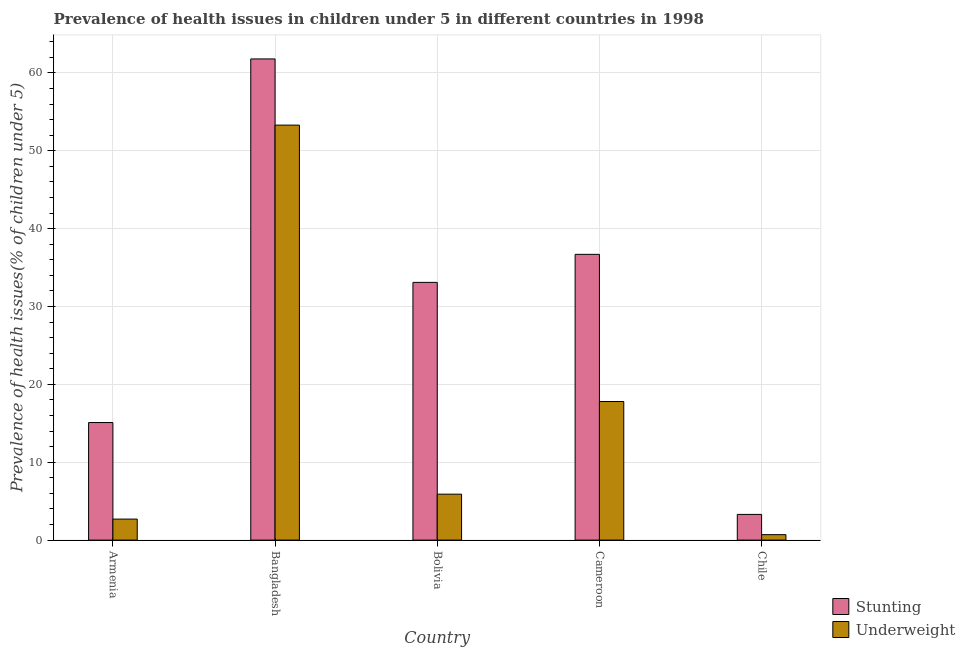How many groups of bars are there?
Provide a succinct answer. 5. How many bars are there on the 4th tick from the right?
Provide a succinct answer. 2. In how many cases, is the number of bars for a given country not equal to the number of legend labels?
Your answer should be very brief. 0. What is the percentage of stunted children in Bolivia?
Offer a very short reply. 33.1. Across all countries, what is the maximum percentage of stunted children?
Make the answer very short. 61.8. Across all countries, what is the minimum percentage of underweight children?
Your response must be concise. 0.7. In which country was the percentage of stunted children maximum?
Keep it short and to the point. Bangladesh. In which country was the percentage of stunted children minimum?
Offer a very short reply. Chile. What is the total percentage of underweight children in the graph?
Give a very brief answer. 80.4. What is the difference between the percentage of stunted children in Armenia and that in Cameroon?
Your answer should be very brief. -21.6. What is the difference between the percentage of underweight children in Bolivia and the percentage of stunted children in Armenia?
Offer a very short reply. -9.2. What is the average percentage of stunted children per country?
Provide a succinct answer. 30. What is the difference between the percentage of underweight children and percentage of stunted children in Bangladesh?
Provide a succinct answer. -8.5. In how many countries, is the percentage of underweight children greater than 30 %?
Your answer should be very brief. 1. What is the ratio of the percentage of stunted children in Cameroon to that in Chile?
Your response must be concise. 11.12. Is the percentage of stunted children in Armenia less than that in Bolivia?
Provide a short and direct response. Yes. What is the difference between the highest and the second highest percentage of stunted children?
Your answer should be compact. 25.1. What is the difference between the highest and the lowest percentage of underweight children?
Your answer should be compact. 52.6. Is the sum of the percentage of underweight children in Bangladesh and Cameroon greater than the maximum percentage of stunted children across all countries?
Offer a very short reply. Yes. What does the 1st bar from the left in Bangladesh represents?
Ensure brevity in your answer.  Stunting. What does the 2nd bar from the right in Bolivia represents?
Offer a very short reply. Stunting. Are all the bars in the graph horizontal?
Your answer should be compact. No. Does the graph contain grids?
Keep it short and to the point. Yes. What is the title of the graph?
Keep it short and to the point. Prevalence of health issues in children under 5 in different countries in 1998. What is the label or title of the Y-axis?
Ensure brevity in your answer.  Prevalence of health issues(% of children under 5). What is the Prevalence of health issues(% of children under 5) in Stunting in Armenia?
Your answer should be very brief. 15.1. What is the Prevalence of health issues(% of children under 5) in Underweight in Armenia?
Offer a terse response. 2.7. What is the Prevalence of health issues(% of children under 5) in Stunting in Bangladesh?
Give a very brief answer. 61.8. What is the Prevalence of health issues(% of children under 5) of Underweight in Bangladesh?
Your answer should be very brief. 53.3. What is the Prevalence of health issues(% of children under 5) of Stunting in Bolivia?
Make the answer very short. 33.1. What is the Prevalence of health issues(% of children under 5) in Underweight in Bolivia?
Your response must be concise. 5.9. What is the Prevalence of health issues(% of children under 5) in Stunting in Cameroon?
Offer a terse response. 36.7. What is the Prevalence of health issues(% of children under 5) of Underweight in Cameroon?
Provide a short and direct response. 17.8. What is the Prevalence of health issues(% of children under 5) of Stunting in Chile?
Give a very brief answer. 3.3. What is the Prevalence of health issues(% of children under 5) of Underweight in Chile?
Provide a short and direct response. 0.7. Across all countries, what is the maximum Prevalence of health issues(% of children under 5) in Stunting?
Keep it short and to the point. 61.8. Across all countries, what is the maximum Prevalence of health issues(% of children under 5) of Underweight?
Give a very brief answer. 53.3. Across all countries, what is the minimum Prevalence of health issues(% of children under 5) of Stunting?
Offer a terse response. 3.3. Across all countries, what is the minimum Prevalence of health issues(% of children under 5) of Underweight?
Your answer should be very brief. 0.7. What is the total Prevalence of health issues(% of children under 5) in Stunting in the graph?
Your response must be concise. 150. What is the total Prevalence of health issues(% of children under 5) in Underweight in the graph?
Provide a succinct answer. 80.4. What is the difference between the Prevalence of health issues(% of children under 5) of Stunting in Armenia and that in Bangladesh?
Keep it short and to the point. -46.7. What is the difference between the Prevalence of health issues(% of children under 5) in Underweight in Armenia and that in Bangladesh?
Ensure brevity in your answer.  -50.6. What is the difference between the Prevalence of health issues(% of children under 5) of Stunting in Armenia and that in Bolivia?
Ensure brevity in your answer.  -18. What is the difference between the Prevalence of health issues(% of children under 5) of Underweight in Armenia and that in Bolivia?
Provide a succinct answer. -3.2. What is the difference between the Prevalence of health issues(% of children under 5) in Stunting in Armenia and that in Cameroon?
Offer a terse response. -21.6. What is the difference between the Prevalence of health issues(% of children under 5) of Underweight in Armenia and that in Cameroon?
Ensure brevity in your answer.  -15.1. What is the difference between the Prevalence of health issues(% of children under 5) of Stunting in Bangladesh and that in Bolivia?
Make the answer very short. 28.7. What is the difference between the Prevalence of health issues(% of children under 5) of Underweight in Bangladesh and that in Bolivia?
Give a very brief answer. 47.4. What is the difference between the Prevalence of health issues(% of children under 5) in Stunting in Bangladesh and that in Cameroon?
Your answer should be compact. 25.1. What is the difference between the Prevalence of health issues(% of children under 5) of Underweight in Bangladesh and that in Cameroon?
Your answer should be compact. 35.5. What is the difference between the Prevalence of health issues(% of children under 5) of Stunting in Bangladesh and that in Chile?
Ensure brevity in your answer.  58.5. What is the difference between the Prevalence of health issues(% of children under 5) in Underweight in Bangladesh and that in Chile?
Make the answer very short. 52.6. What is the difference between the Prevalence of health issues(% of children under 5) in Stunting in Bolivia and that in Cameroon?
Offer a very short reply. -3.6. What is the difference between the Prevalence of health issues(% of children under 5) in Underweight in Bolivia and that in Cameroon?
Provide a short and direct response. -11.9. What is the difference between the Prevalence of health issues(% of children under 5) in Stunting in Bolivia and that in Chile?
Keep it short and to the point. 29.8. What is the difference between the Prevalence of health issues(% of children under 5) in Stunting in Cameroon and that in Chile?
Provide a succinct answer. 33.4. What is the difference between the Prevalence of health issues(% of children under 5) in Stunting in Armenia and the Prevalence of health issues(% of children under 5) in Underweight in Bangladesh?
Offer a terse response. -38.2. What is the difference between the Prevalence of health issues(% of children under 5) of Stunting in Bangladesh and the Prevalence of health issues(% of children under 5) of Underweight in Bolivia?
Provide a short and direct response. 55.9. What is the difference between the Prevalence of health issues(% of children under 5) in Stunting in Bangladesh and the Prevalence of health issues(% of children under 5) in Underweight in Cameroon?
Provide a short and direct response. 44. What is the difference between the Prevalence of health issues(% of children under 5) in Stunting in Bangladesh and the Prevalence of health issues(% of children under 5) in Underweight in Chile?
Provide a short and direct response. 61.1. What is the difference between the Prevalence of health issues(% of children under 5) in Stunting in Bolivia and the Prevalence of health issues(% of children under 5) in Underweight in Cameroon?
Keep it short and to the point. 15.3. What is the difference between the Prevalence of health issues(% of children under 5) in Stunting in Bolivia and the Prevalence of health issues(% of children under 5) in Underweight in Chile?
Ensure brevity in your answer.  32.4. What is the difference between the Prevalence of health issues(% of children under 5) of Stunting in Cameroon and the Prevalence of health issues(% of children under 5) of Underweight in Chile?
Offer a terse response. 36. What is the average Prevalence of health issues(% of children under 5) in Underweight per country?
Your answer should be compact. 16.08. What is the difference between the Prevalence of health issues(% of children under 5) of Stunting and Prevalence of health issues(% of children under 5) of Underweight in Bangladesh?
Offer a very short reply. 8.5. What is the difference between the Prevalence of health issues(% of children under 5) of Stunting and Prevalence of health issues(% of children under 5) of Underweight in Bolivia?
Make the answer very short. 27.2. What is the difference between the Prevalence of health issues(% of children under 5) in Stunting and Prevalence of health issues(% of children under 5) in Underweight in Cameroon?
Ensure brevity in your answer.  18.9. What is the ratio of the Prevalence of health issues(% of children under 5) in Stunting in Armenia to that in Bangladesh?
Offer a terse response. 0.24. What is the ratio of the Prevalence of health issues(% of children under 5) of Underweight in Armenia to that in Bangladesh?
Your answer should be very brief. 0.05. What is the ratio of the Prevalence of health issues(% of children under 5) of Stunting in Armenia to that in Bolivia?
Provide a short and direct response. 0.46. What is the ratio of the Prevalence of health issues(% of children under 5) in Underweight in Armenia to that in Bolivia?
Provide a short and direct response. 0.46. What is the ratio of the Prevalence of health issues(% of children under 5) in Stunting in Armenia to that in Cameroon?
Provide a short and direct response. 0.41. What is the ratio of the Prevalence of health issues(% of children under 5) of Underweight in Armenia to that in Cameroon?
Keep it short and to the point. 0.15. What is the ratio of the Prevalence of health issues(% of children under 5) of Stunting in Armenia to that in Chile?
Provide a succinct answer. 4.58. What is the ratio of the Prevalence of health issues(% of children under 5) in Underweight in Armenia to that in Chile?
Give a very brief answer. 3.86. What is the ratio of the Prevalence of health issues(% of children under 5) in Stunting in Bangladesh to that in Bolivia?
Your answer should be compact. 1.87. What is the ratio of the Prevalence of health issues(% of children under 5) of Underweight in Bangladesh to that in Bolivia?
Provide a short and direct response. 9.03. What is the ratio of the Prevalence of health issues(% of children under 5) in Stunting in Bangladesh to that in Cameroon?
Ensure brevity in your answer.  1.68. What is the ratio of the Prevalence of health issues(% of children under 5) of Underweight in Bangladesh to that in Cameroon?
Offer a very short reply. 2.99. What is the ratio of the Prevalence of health issues(% of children under 5) in Stunting in Bangladesh to that in Chile?
Offer a very short reply. 18.73. What is the ratio of the Prevalence of health issues(% of children under 5) of Underweight in Bangladesh to that in Chile?
Ensure brevity in your answer.  76.14. What is the ratio of the Prevalence of health issues(% of children under 5) of Stunting in Bolivia to that in Cameroon?
Your answer should be compact. 0.9. What is the ratio of the Prevalence of health issues(% of children under 5) in Underweight in Bolivia to that in Cameroon?
Ensure brevity in your answer.  0.33. What is the ratio of the Prevalence of health issues(% of children under 5) in Stunting in Bolivia to that in Chile?
Make the answer very short. 10.03. What is the ratio of the Prevalence of health issues(% of children under 5) of Underweight in Bolivia to that in Chile?
Your response must be concise. 8.43. What is the ratio of the Prevalence of health issues(% of children under 5) of Stunting in Cameroon to that in Chile?
Keep it short and to the point. 11.12. What is the ratio of the Prevalence of health issues(% of children under 5) in Underweight in Cameroon to that in Chile?
Offer a very short reply. 25.43. What is the difference between the highest and the second highest Prevalence of health issues(% of children under 5) of Stunting?
Make the answer very short. 25.1. What is the difference between the highest and the second highest Prevalence of health issues(% of children under 5) in Underweight?
Provide a succinct answer. 35.5. What is the difference between the highest and the lowest Prevalence of health issues(% of children under 5) in Stunting?
Keep it short and to the point. 58.5. What is the difference between the highest and the lowest Prevalence of health issues(% of children under 5) of Underweight?
Keep it short and to the point. 52.6. 